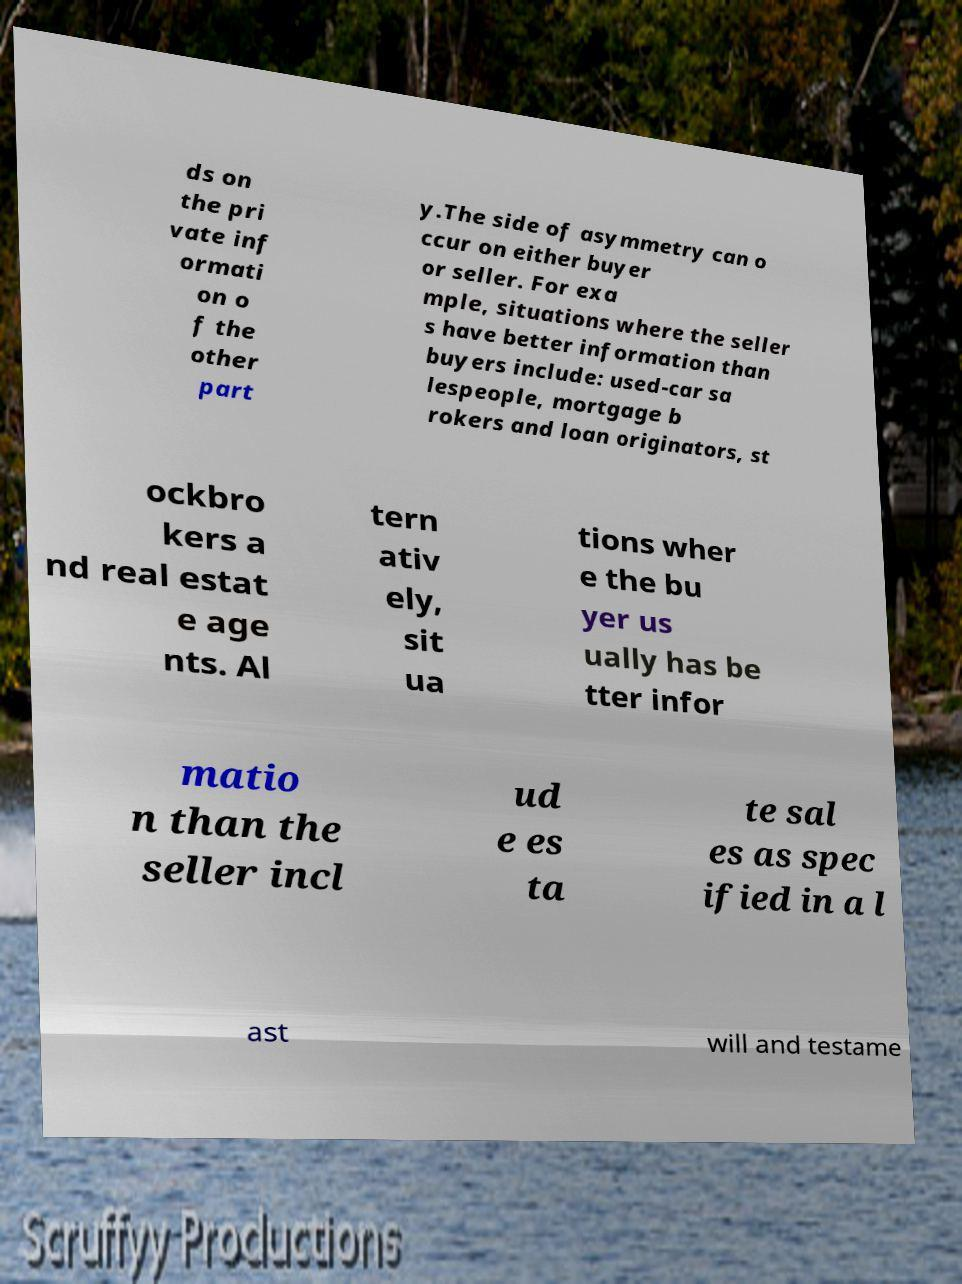There's text embedded in this image that I need extracted. Can you transcribe it verbatim? ds on the pri vate inf ormati on o f the other part y.The side of asymmetry can o ccur on either buyer or seller. For exa mple, situations where the seller s have better information than buyers include: used-car sa lespeople, mortgage b rokers and loan originators, st ockbro kers a nd real estat e age nts. Al tern ativ ely, sit ua tions wher e the bu yer us ually has be tter infor matio n than the seller incl ud e es ta te sal es as spec ified in a l ast will and testame 